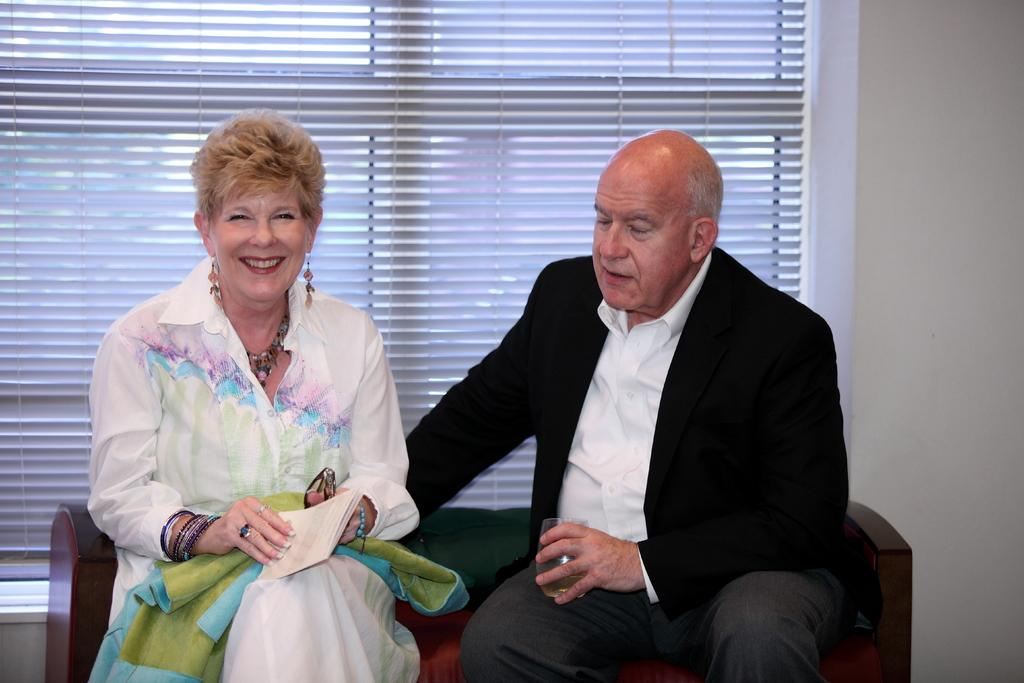Who is present in the image? There is a man and a woman in the image. What are they doing in the image? Both the man and woman are sitting on a sofa. What is the woman holding in the image? The woman is holding a book. What can be seen on the wall in the image? There is a window on the wall. What type of cushion is being used to support the wire in the image? There is no cushion or wire present in the image. How is the ice being used in the image? There is no ice present in the image. 